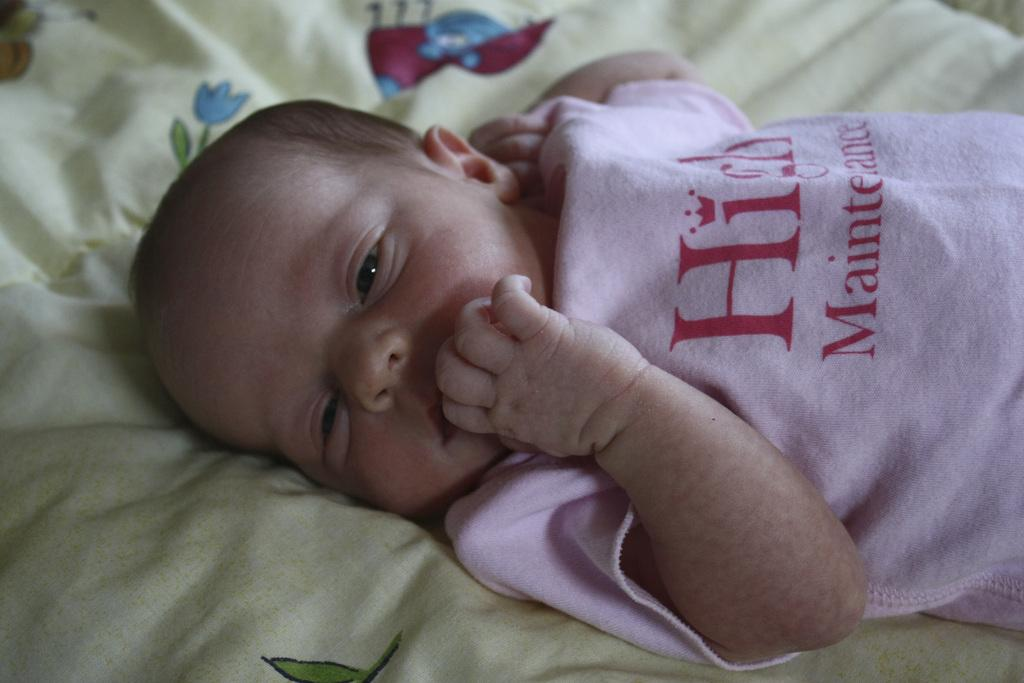What is the main subject of the image? There is a baby in the image. What is the baby lying on? The baby is lying on a cloth. What type of roof can be seen in the image? There is no roof present in the image; it features a baby lying on a cloth. What type of coach is visible in the image? There is no coach present in the image; it features a baby lying on a cloth. 